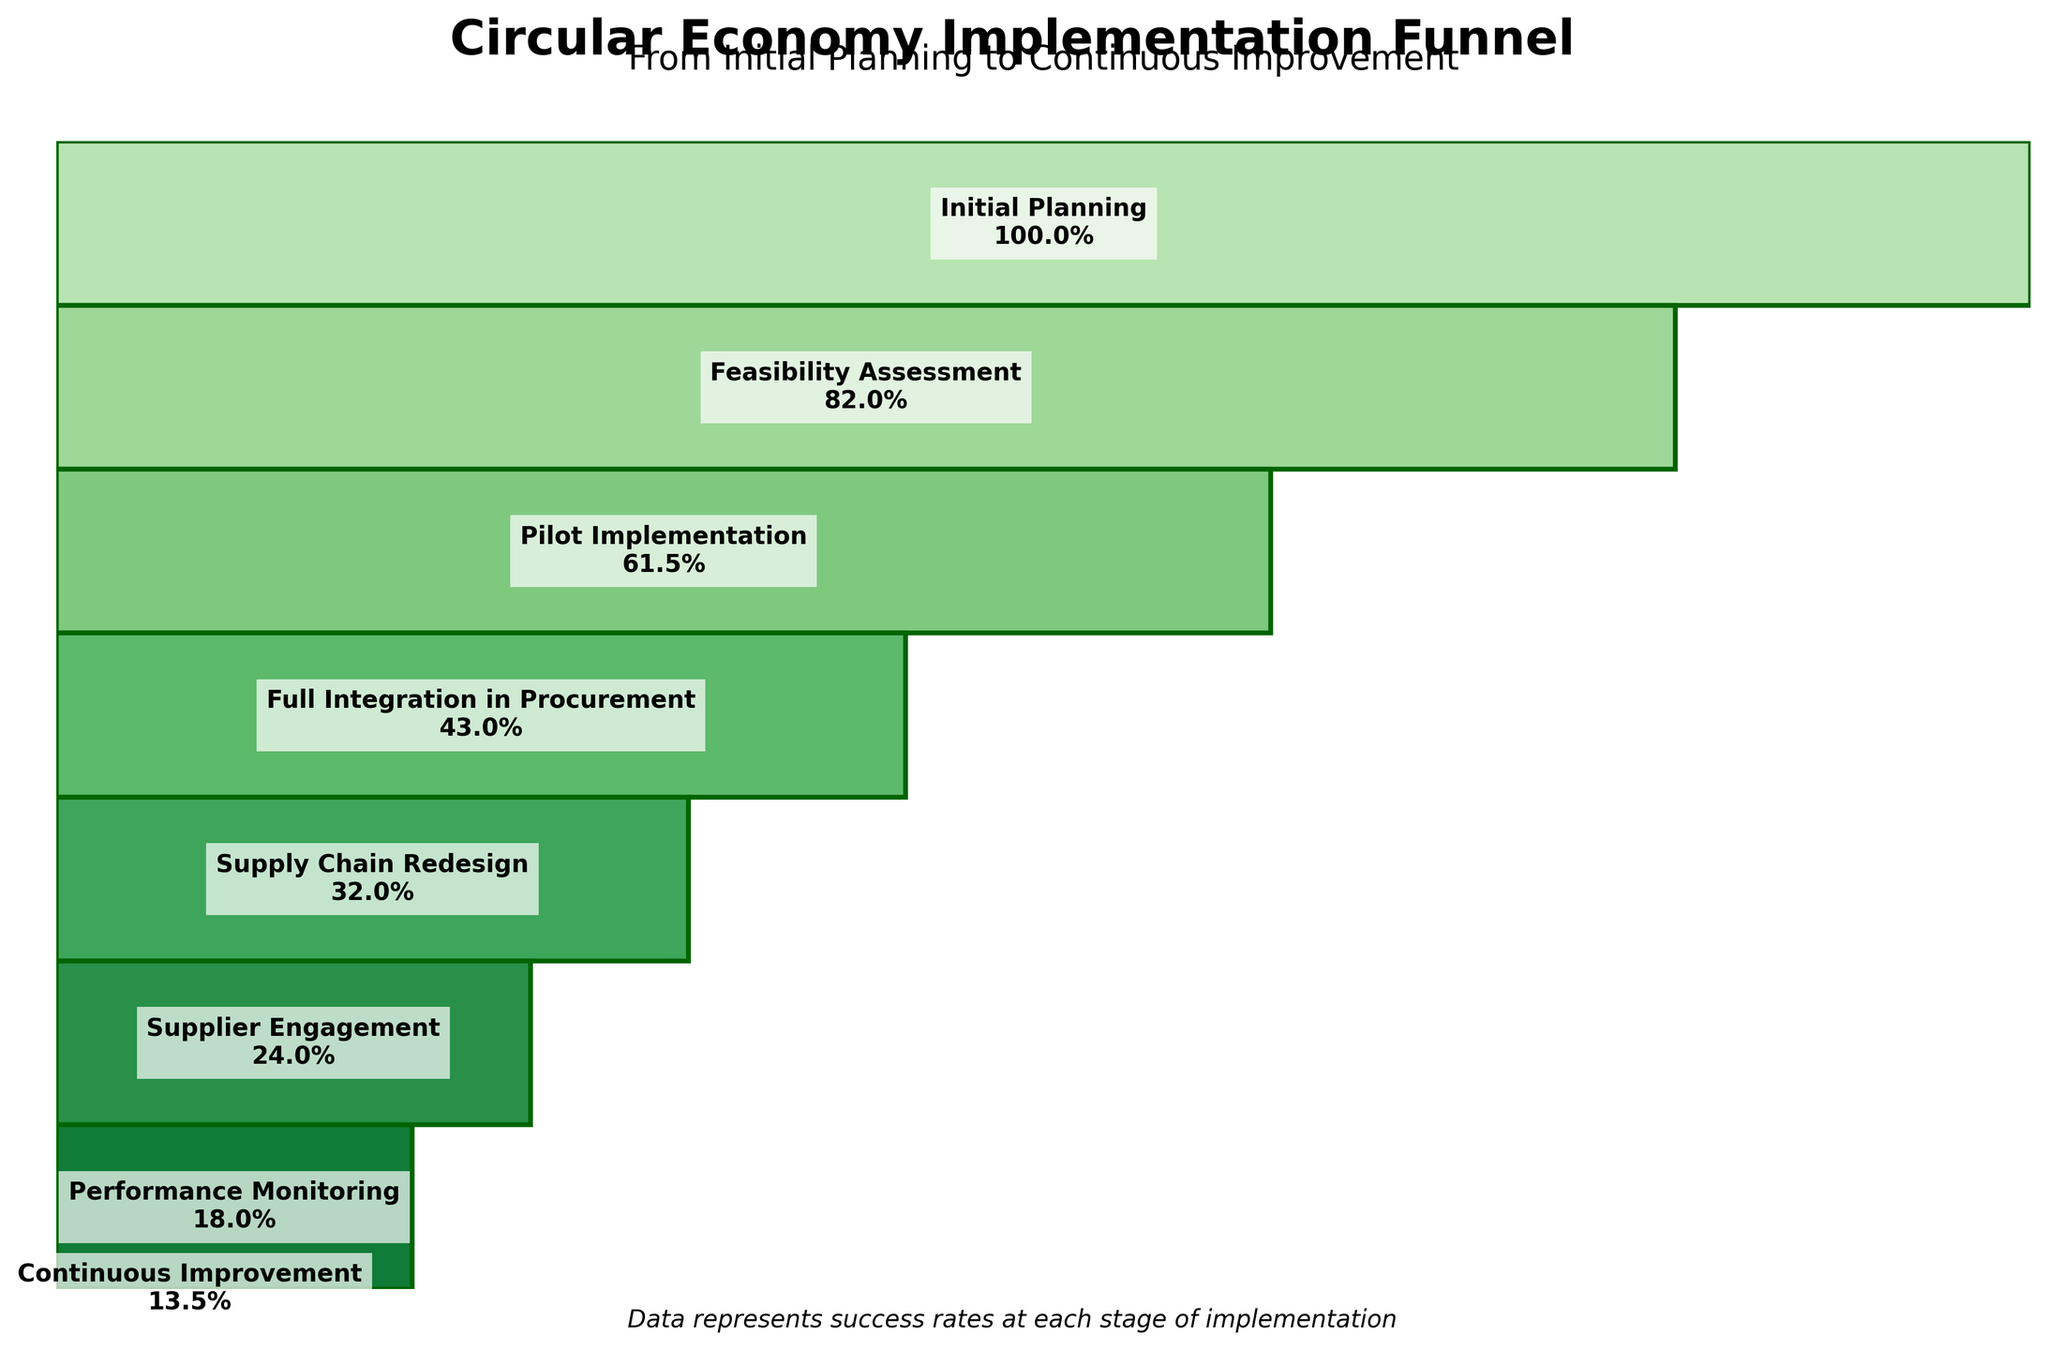What is the title of the funnel chart? The title is prominently displayed at the top of the figure, indicating the main topic of the chart.
Answer: Circular Economy Implementation Funnel How many stages are represented in the chart? By counting each segment or label along the funnel, you can see that it contains 8 distinct stages.
Answer: 8 What percentage of companies move from Feasibility Assessment to Pilot Implementation? Subtract the percentage of companies in the Pilot Implementation stage from those in the Feasibility Assessment stage (82% - 61.5%).
Answer: 20.5% Which stage has the lowest percentage of companies in the funnel? By observing the width and the labels, the Continuous Improvement stage has the smallest percentage.
Answer: Continuous Improvement How many companies are fully engaged in Supply Chain Redesign? The percentage for this stage is 32%, which is 320 out of the initial 1000 companies.
Answer: 320 Compare the percentage drop between Pilot Implementation and Full Integration in Procurement to that between Supplier Engagement and Performance Monitoring. Which is larger? Calculate the drops: Pilot to Full Integration (61.5% - 43% = 18.5%), and Supplier Engagement to Performance Monitoring (24% - 18% = 6%). The first drop is larger.
Answer: Pilot to Full Integration in Procurement What is the average percentage of companies successfully completing the first three stages (Initial Planning, Feasibility Assessment, Pilot Implementation)? Add the percentages of the three stages (100% + 82% + 61.5%) and divide by 3.
Answer: 81.17% From which stage to which stage is there the highest percentage decrease? Calculate the percentage decreases between all consecutive stages. The highest drop is from Feasibility Assessment to Pilot Implementation (82% - 61.5% = 20.5%).
Answer: Feasibility Assessment to Pilot Implementation If 50 companies proceeded from Performance Monitoring to Continuous Improvement, what percentage does this represent of the initial number of companies? Calculate 50 as a percentage of the initial 1000 companies (50/1000 * 100%).
Answer: 5% Arrange the stages in descending order based on percentage completion. List the stages from the highest to the lowest percentage based on the data provided.
Answer: Initial Planning, Feasibility Assessment, Pilot Implementation, Full Integration in Procurement, Supply Chain Redesign, Supplier Engagement, Performance Monitoring, Continuous Improvement 